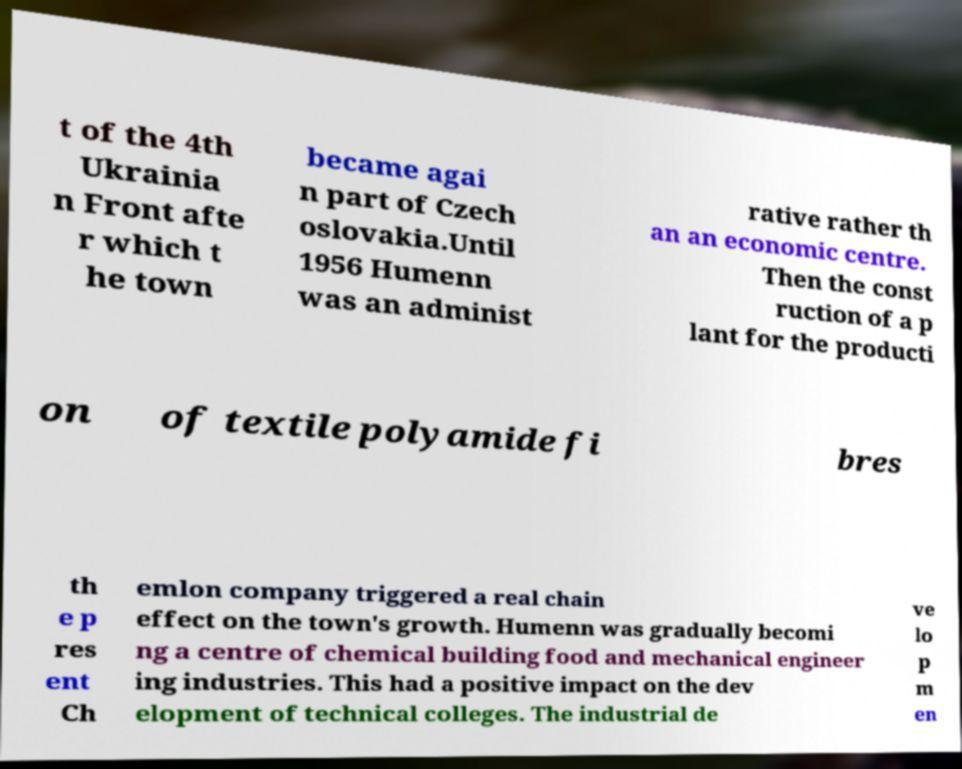Can you accurately transcribe the text from the provided image for me? t of the 4th Ukrainia n Front afte r which t he town became agai n part of Czech oslovakia.Until 1956 Humenn was an administ rative rather th an an economic centre. Then the const ruction of a p lant for the producti on of textile polyamide fi bres th e p res ent Ch emlon company triggered a real chain effect on the town's growth. Humenn was gradually becomi ng a centre of chemical building food and mechanical engineer ing industries. This had a positive impact on the dev elopment of technical colleges. The industrial de ve lo p m en 